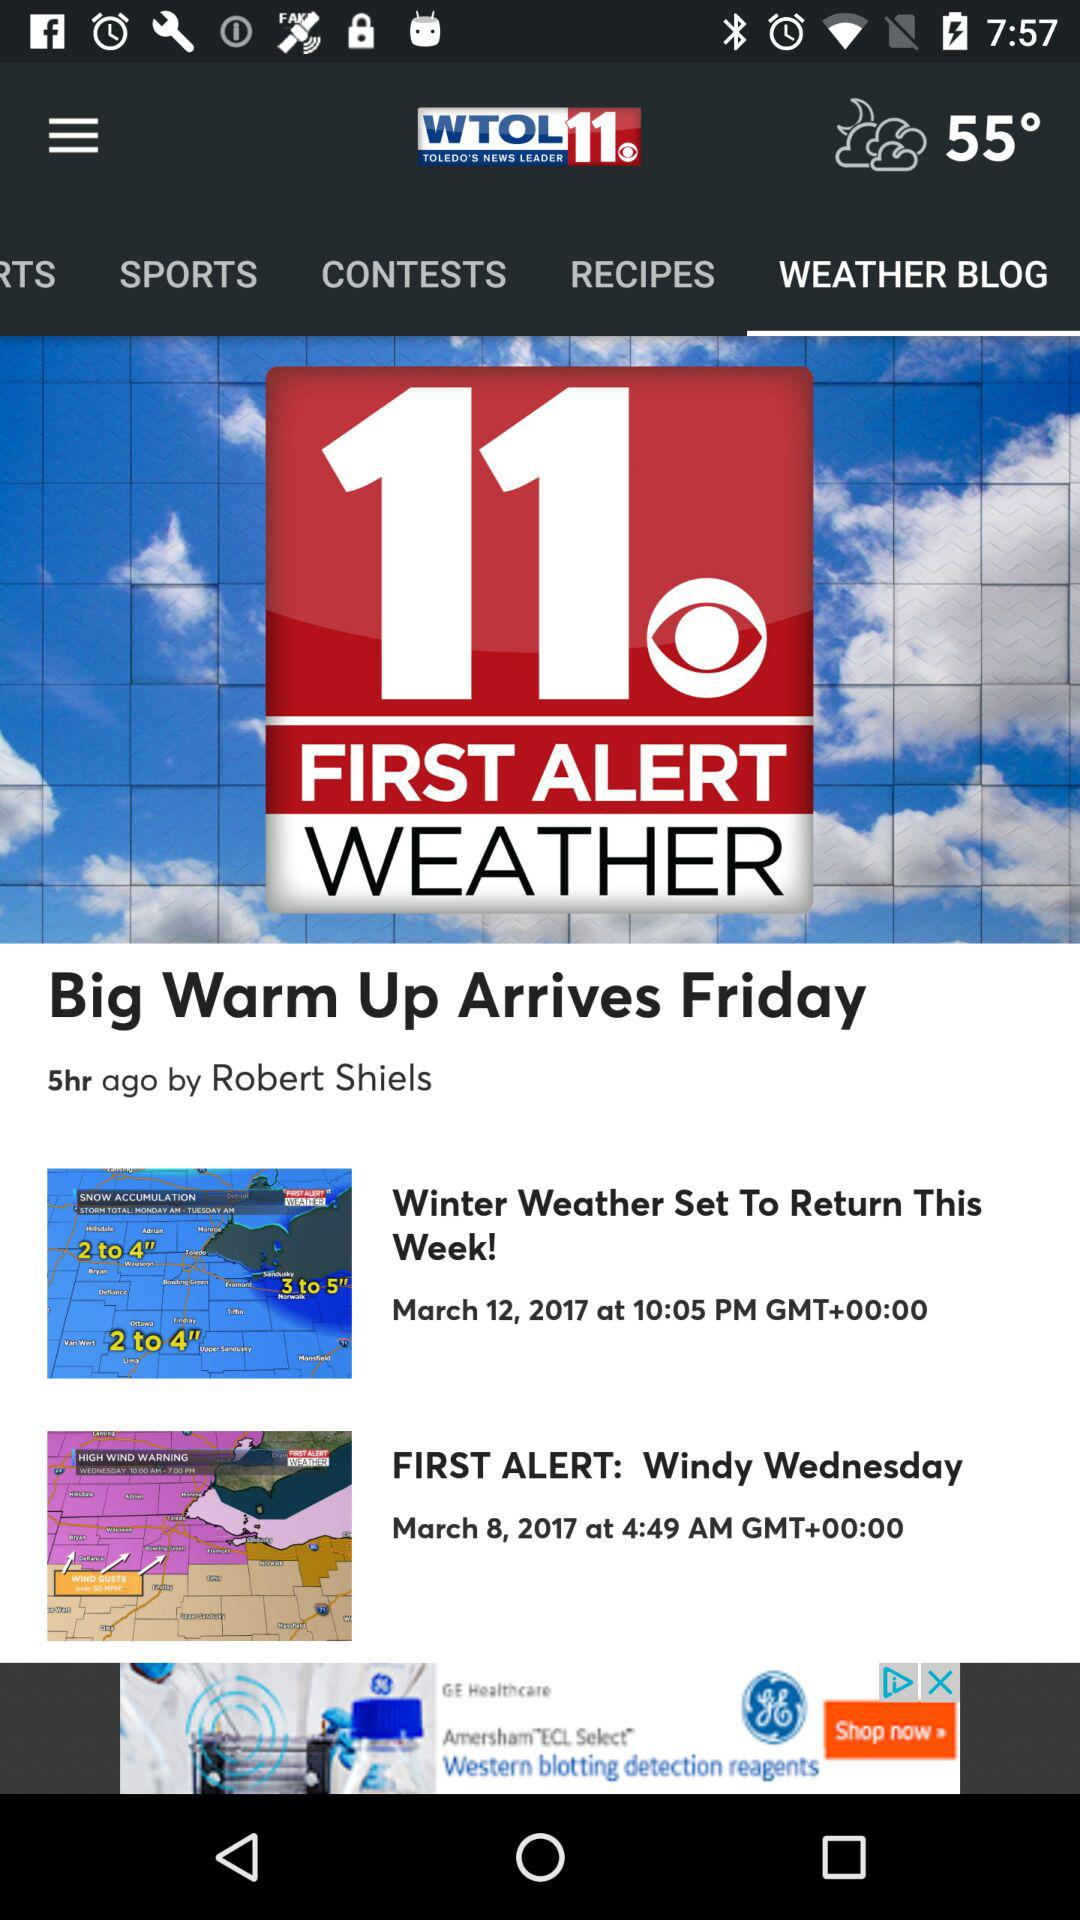What is the temperature shown on the screen? The temperature shown on the screen is 55°. 